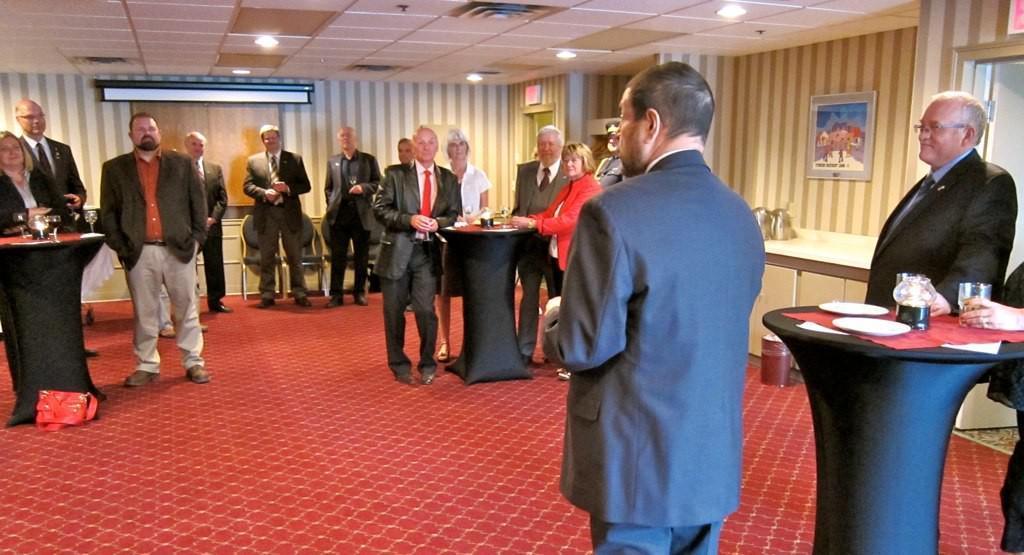In one or two sentences, can you explain what this image depicts? In the middle of the image few people are standing. Bottom right side of the image there is a table, On the table there is a saucer and glass. Top right side of the image there is a roof and light. Top left side of the image there is a wall. 